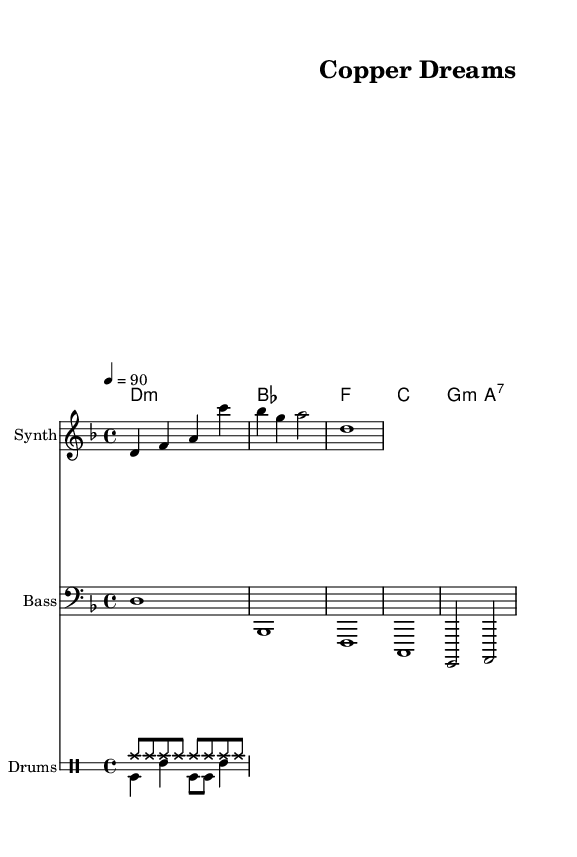What is the key signature of this music? The key signature is D minor, indicated by one flat (B flat) in the music.
Answer: D minor What is the time signature of the piece? The time signature is 4/4, which means there are four beats per measure and each quarter note gets one beat.
Answer: 4/4 What is the tempo marking for this score? The tempo marking indicates a speed of 90 beats per minute, shown as "4 = 90" at the beginning of the score.
Answer: 90 How many measures are in the melody part? The melody part contains four measures; each section of notes corresponds to one measure based on the time signature.
Answer: 4 What is the name of the piece? The title of the piece, as indicated in the header, is "Copper Dreams."
Answer: Copper Dreams Which instrument is playing the melody? The melody is played by the "Synth," as indicated in the staff label.
Answer: Synth What kind of rhythm does the drum pattern have? The drum pattern features a steady hi-hat rhythm with added bass drum and snare variations, indicative of dance music.
Answer: Dance rhythm 